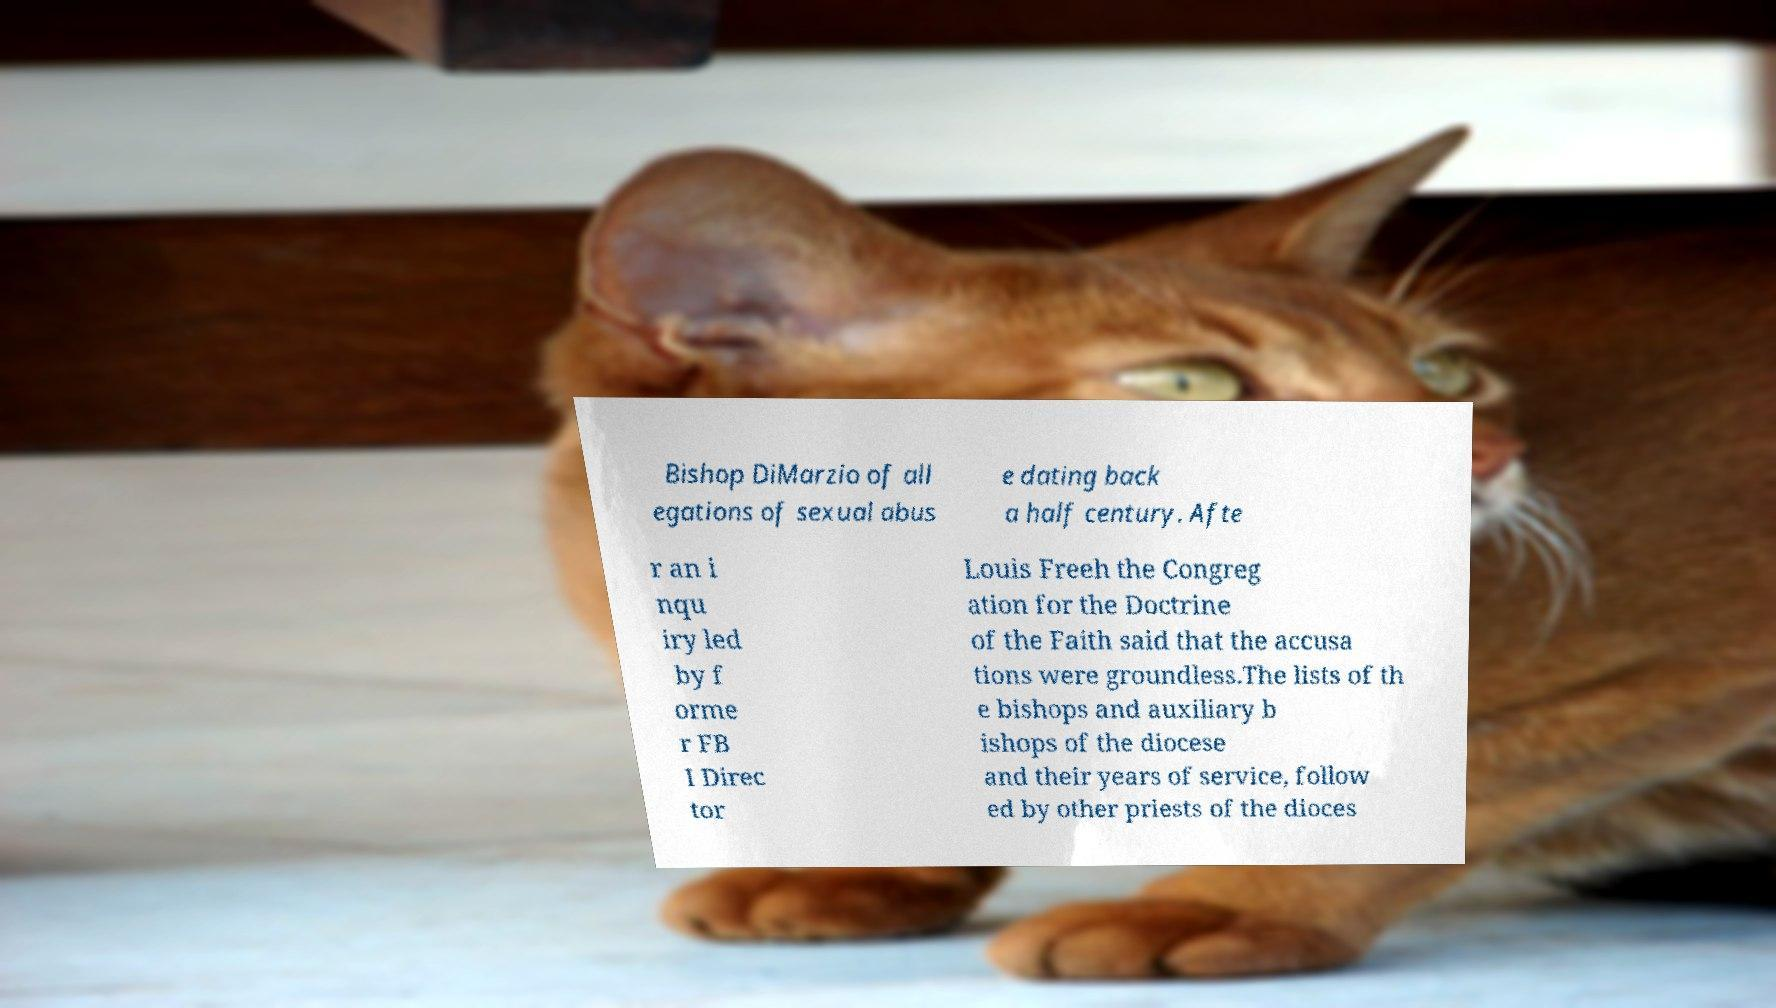There's text embedded in this image that I need extracted. Can you transcribe it verbatim? Bishop DiMarzio of all egations of sexual abus e dating back a half century. Afte r an i nqu iry led by f orme r FB I Direc tor Louis Freeh the Congreg ation for the Doctrine of the Faith said that the accusa tions were groundless.The lists of th e bishops and auxiliary b ishops of the diocese and their years of service, follow ed by other priests of the dioces 